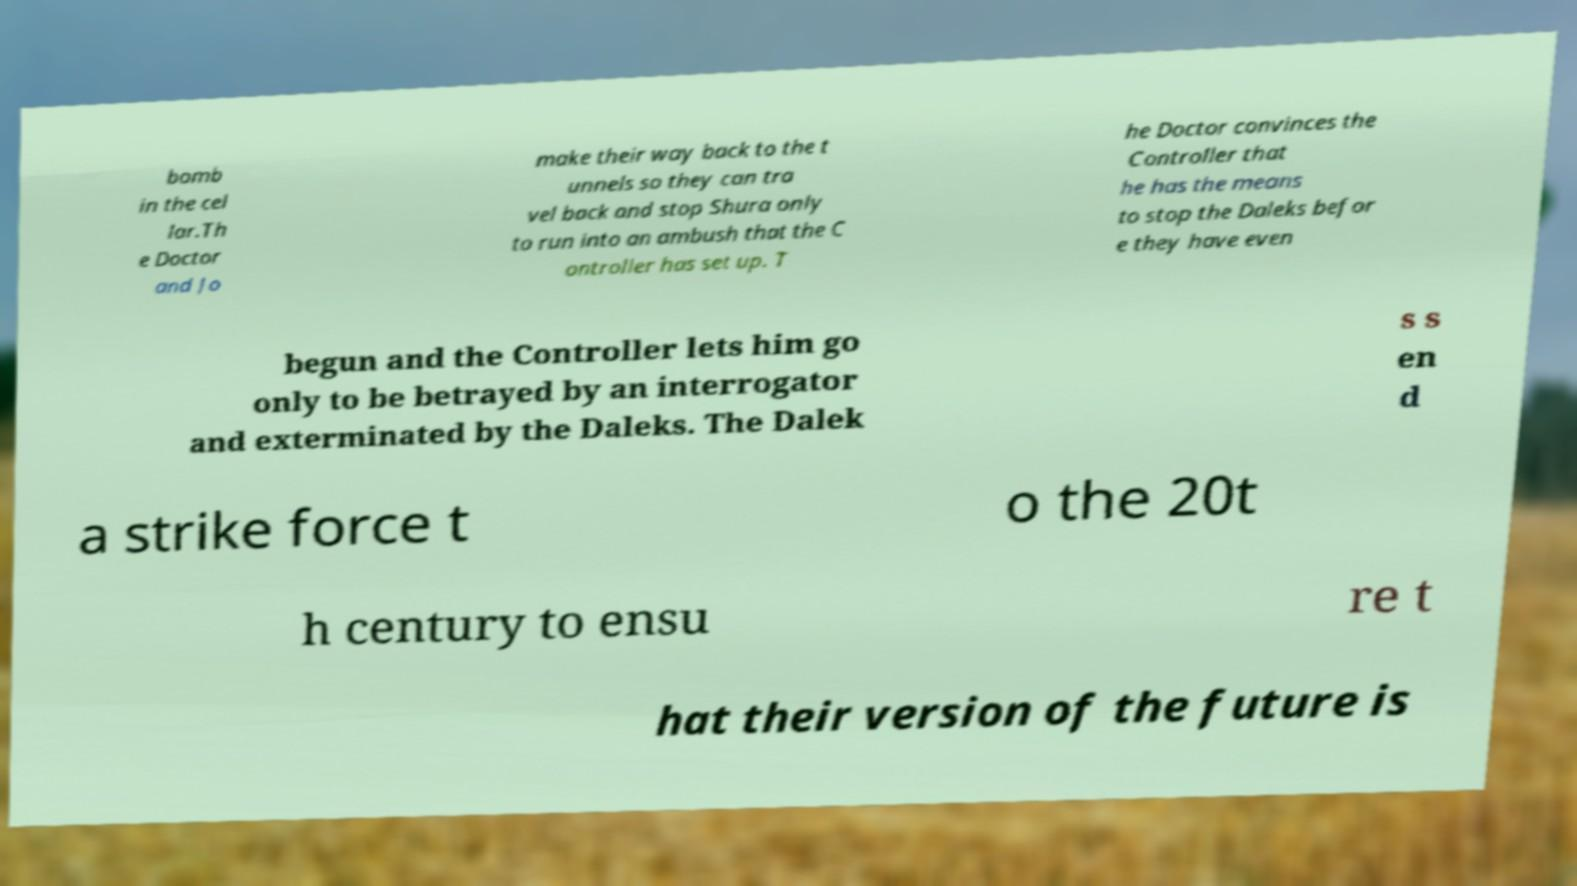Could you extract and type out the text from this image? bomb in the cel lar.Th e Doctor and Jo make their way back to the t unnels so they can tra vel back and stop Shura only to run into an ambush that the C ontroller has set up. T he Doctor convinces the Controller that he has the means to stop the Daleks befor e they have even begun and the Controller lets him go only to be betrayed by an interrogator and exterminated by the Daleks. The Dalek s s en d a strike force t o the 20t h century to ensu re t hat their version of the future is 